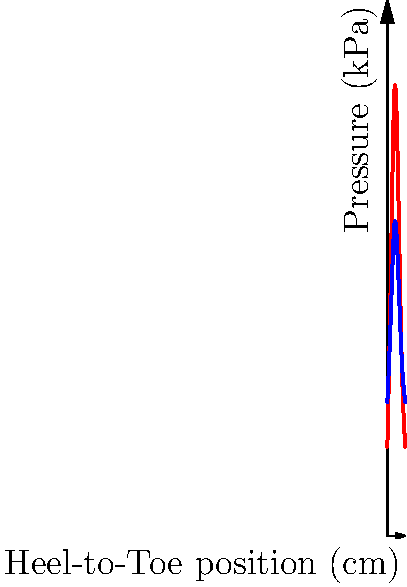As a career coach developing a training program for footwear designers, you're analyzing pressure distribution maps of two running shoe designs. The graph shows the pressure distribution along the heel-to-toe axis for Designs A and B. Which design appears to have better biomechanical efficiency for reducing peak pressures during running, and how might this information be used in a career development context for footwear designers? To answer this question, let's analyze the pressure distribution maps step-by-step:

1. Interpret the graph:
   - The x-axis represents the heel-to-toe position (0 cm being the heel, 10 cm being the toe).
   - The y-axis shows the pressure in kPa (kilopascals).
   - Red line represents Design A, blue line represents Design B.

2. Compare peak pressures:
   - Design A has a higher peak pressure of about 250 kPa in the midfoot region.
   - Design B has a lower peak pressure of about 175 kPa, also in the midfoot region.

3. Analyze pressure distribution:
   - Design A shows more pronounced peaks and valleys, indicating less even distribution.
   - Design B demonstrates a more uniform pressure distribution across the foot.

4. Consider biomechanical efficiency:
   - Lower peak pressures generally indicate better shock absorption and reduced stress on the foot.
   - More even pressure distribution suggests better weight distribution and potentially improved stability.

5. Conclude on efficiency:
   - Design B appears to have better biomechanical efficiency due to lower peak pressures and more even distribution.

6. Career development context:
   - This information can be used to train footwear designers on:
     a) The importance of pressure distribution in shoe design.
     b) How to interpret and use pressure maps to improve designs.
     c) The relationship between pressure distribution and biomechanical efficiency.
   - It can also be used to develop skills in:
     a) Data analysis and interpretation.
     b) Applying scientific principles to practical design challenges.
     c) Understanding the impact of design choices on user experience and performance.
Answer: Design B; use for training in data interpretation, biomechanics application, and innovative design techniques. 